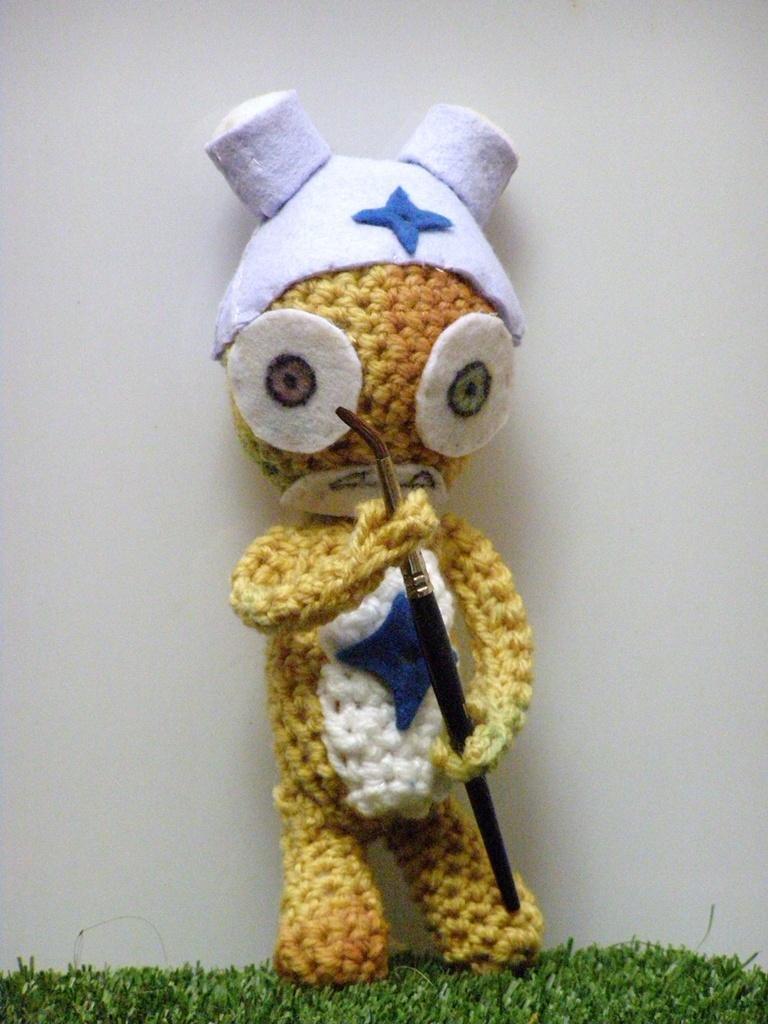How would you summarize this image in a sentence or two? In this picture, we see the stuffed toy is holding a paint brush. It is in yellow and white color. At the bottom, we see the artificial grass. In the background, it is white in color. It might be a wall. 